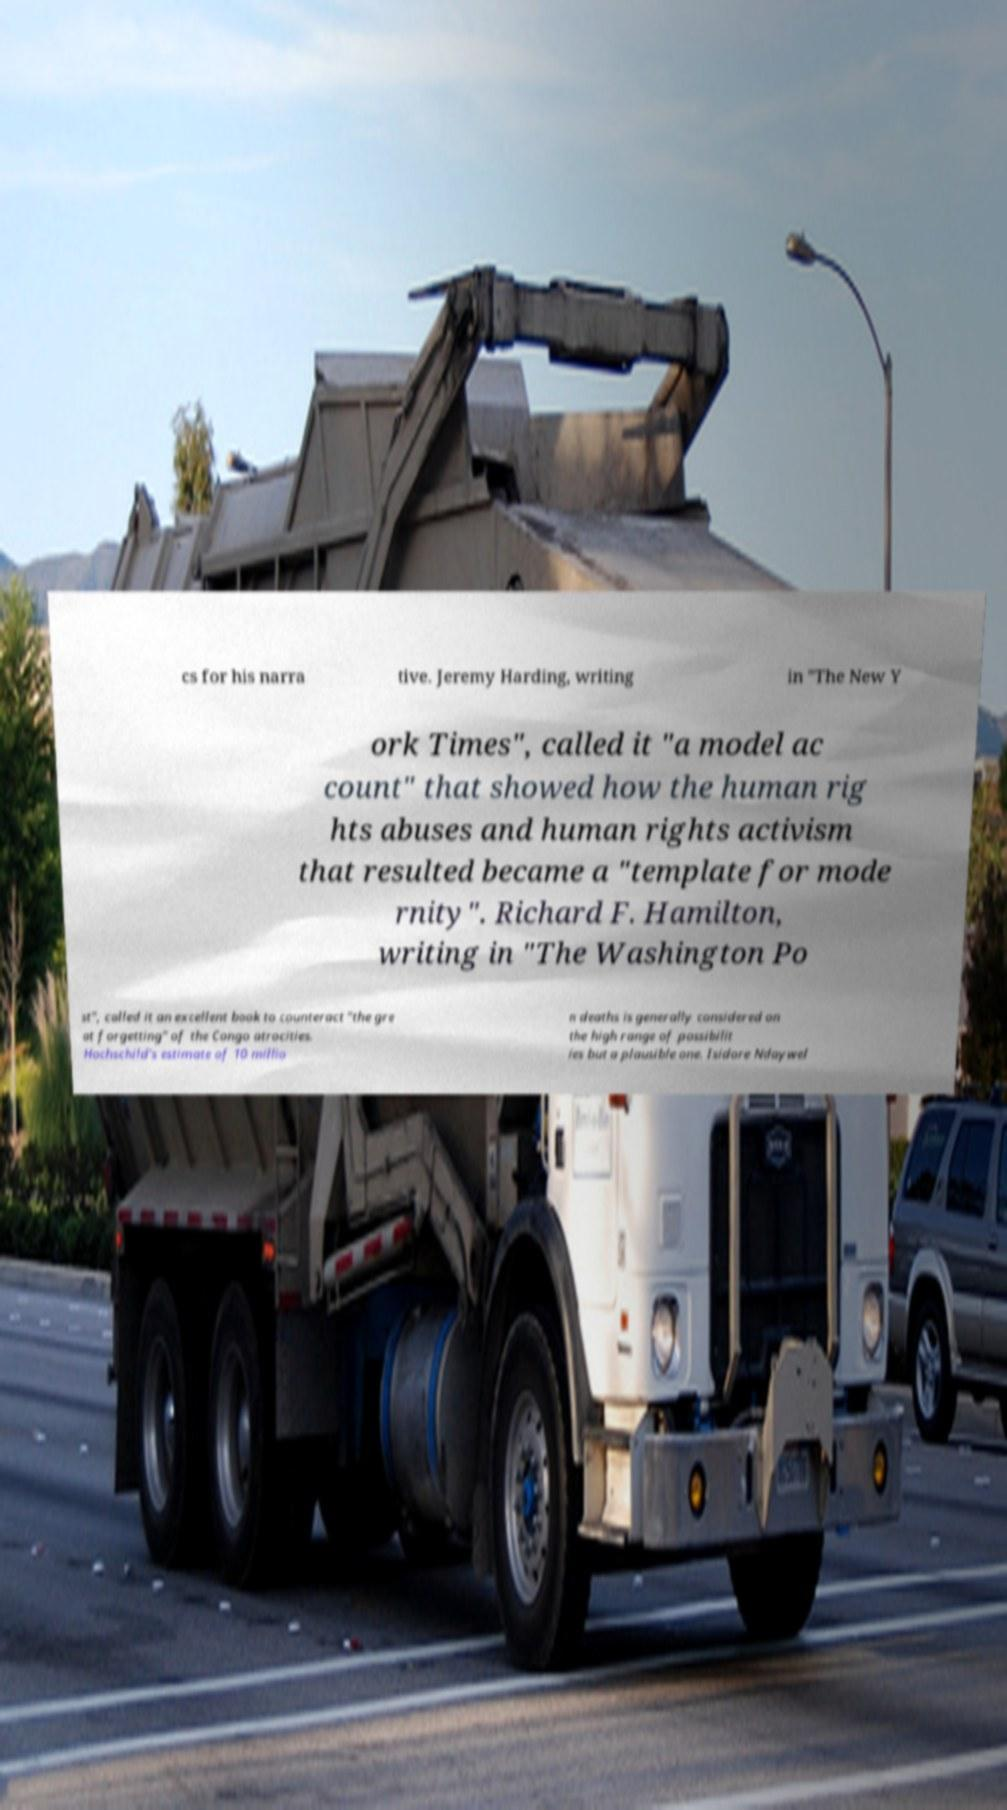Please read and relay the text visible in this image. What does it say? cs for his narra tive. Jeremy Harding, writing in "The New Y ork Times", called it "a model ac count" that showed how the human rig hts abuses and human rights activism that resulted became a "template for mode rnity". Richard F. Hamilton, writing in "The Washington Po st", called it an excellent book to counteract "the gre at forgetting" of the Congo atrocities. Hochschild's estimate of 10 millio n deaths is generally considered on the high range of possibilit ies but a plausible one. Isidore Ndaywel 